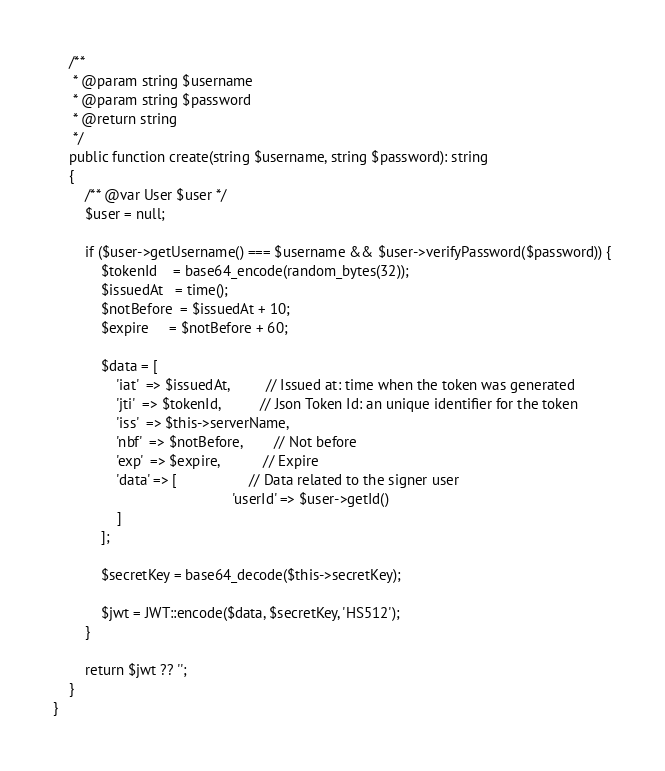<code> <loc_0><loc_0><loc_500><loc_500><_PHP_>
    /**
     * @param string $username
     * @param string $password
     * @return string
     */
    public function create(string $username, string $password): string
    {
        /** @var User $user */
        $user = null;

        if ($user->getUsername() === $username && $user->verifyPassword($password)) {
            $tokenId    = base64_encode(random_bytes(32));
            $issuedAt   = time();
            $notBefore  = $issuedAt + 10;
            $expire     = $notBefore + 60;

            $data = [
                'iat'  => $issuedAt,         // Issued at: time when the token was generated
                'jti'  => $tokenId,          // Json Token Id: an unique identifier for the token
                'iss'  => $this->serverName,
                'nbf'  => $notBefore,        // Not before
                'exp'  => $expire,           // Expire
                'data' => [                  // Data related to the signer user
                                             'userId' => $user->getId()
                ]
            ];

            $secretKey = base64_decode($this->secretKey);

            $jwt = JWT::encode($data, $secretKey, 'HS512');
        }

        return $jwt ?? '';
    }
}
</code> 